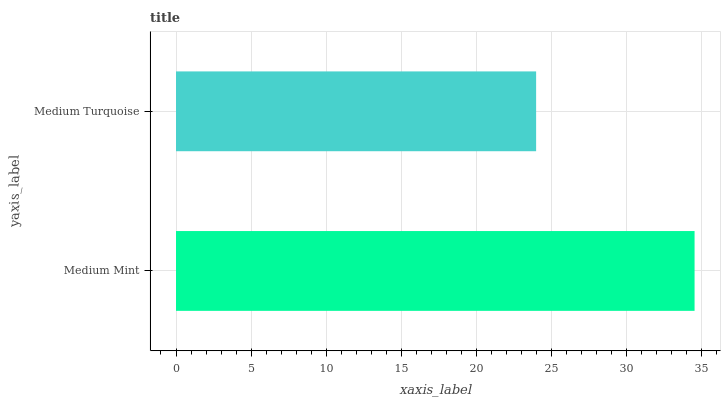Is Medium Turquoise the minimum?
Answer yes or no. Yes. Is Medium Mint the maximum?
Answer yes or no. Yes. Is Medium Turquoise the maximum?
Answer yes or no. No. Is Medium Mint greater than Medium Turquoise?
Answer yes or no. Yes. Is Medium Turquoise less than Medium Mint?
Answer yes or no. Yes. Is Medium Turquoise greater than Medium Mint?
Answer yes or no. No. Is Medium Mint less than Medium Turquoise?
Answer yes or no. No. Is Medium Mint the high median?
Answer yes or no. Yes. Is Medium Turquoise the low median?
Answer yes or no. Yes. Is Medium Turquoise the high median?
Answer yes or no. No. Is Medium Mint the low median?
Answer yes or no. No. 